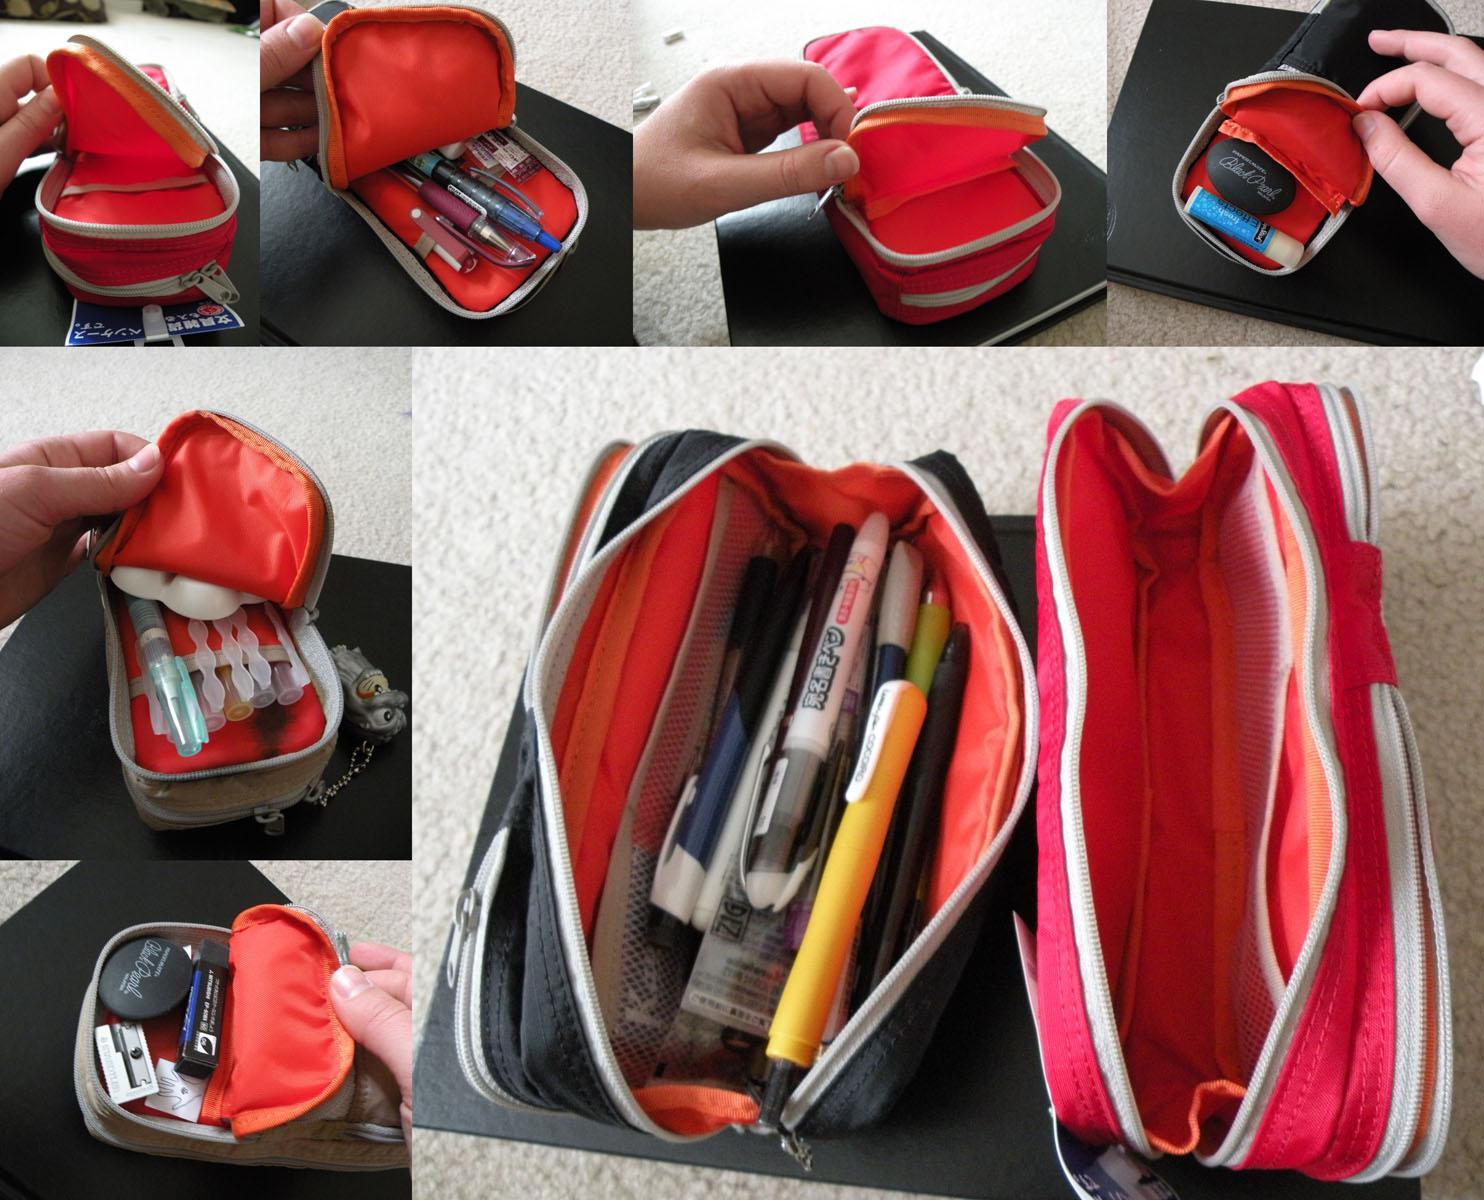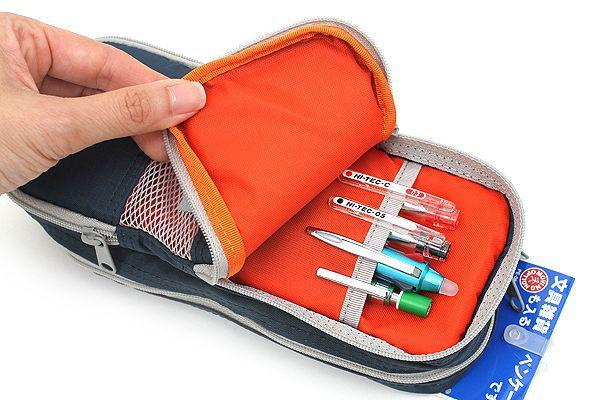The first image is the image on the left, the second image is the image on the right. Evaluate the accuracy of this statement regarding the images: "An image shows one soft-sided case that is zipped shut.". Is it true? Answer yes or no. No. 